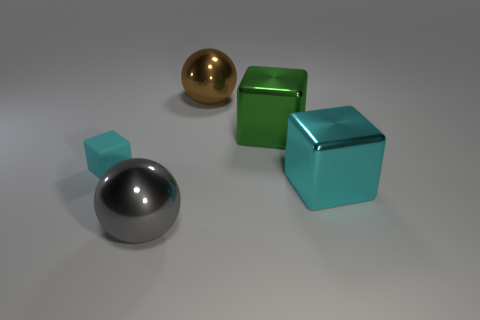The large shiny object that is both left of the large green metal cube and behind the small matte thing has what shape? sphere 